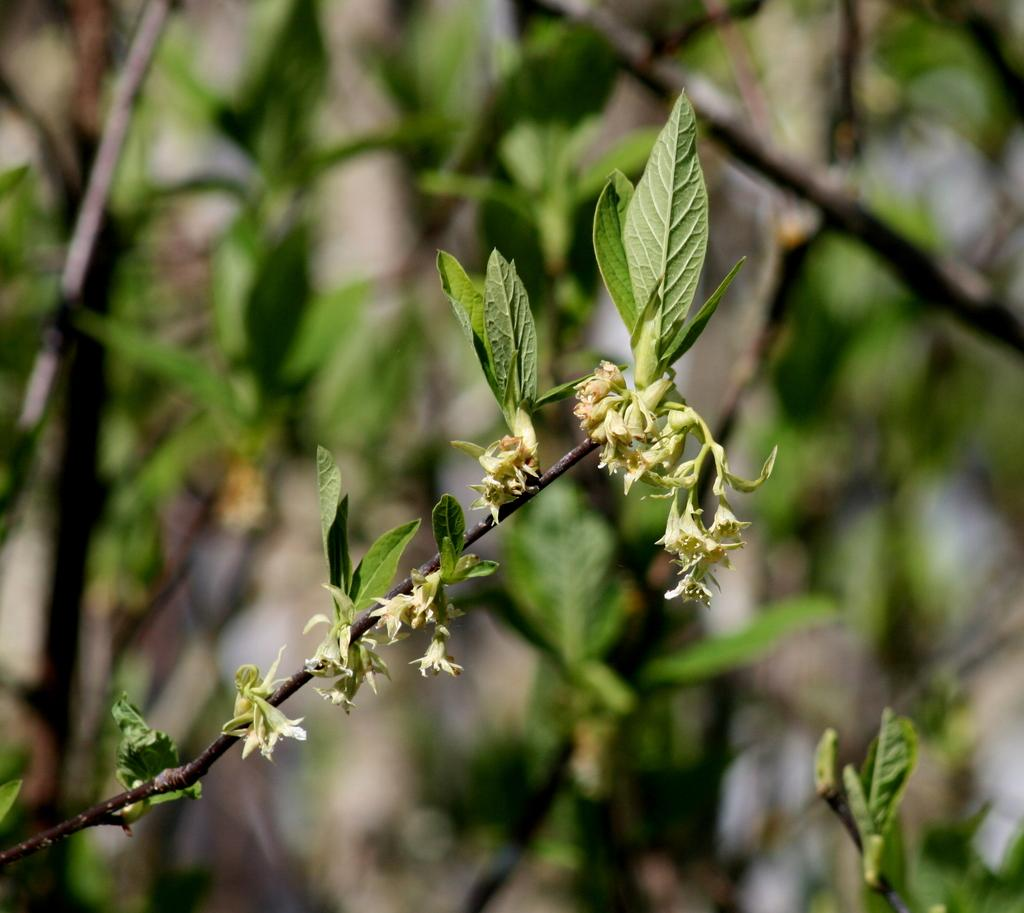What type of flora can be seen in the image? There are flowers in the image. What color are the flowers? The flowers are white in color. What else can be seen in the background of the image? There are plants in the background of the image. What color are the plants? The plants are green in color. Can you tell me how many bikes are parked next to the flowers in the image? There are no bikes present in the image; it only features flowers and plants. What type of weather condition is depicted by the fog in the image? There is no fog present in the image; it only features flowers and plants. 